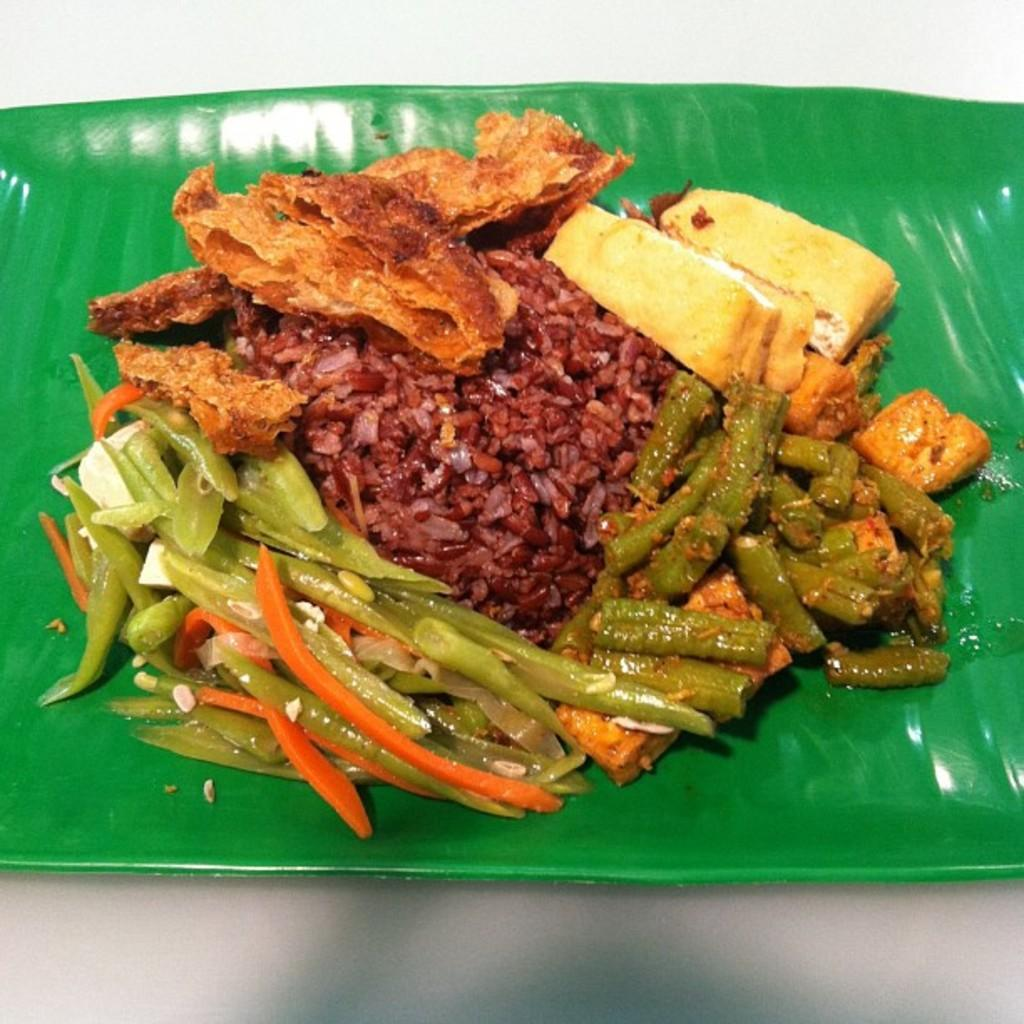What type of food items can be seen in the image? There are food items in the image, but their specific types are not mentioned. How are the food items arranged or presented in the image? The food items are kept on a banana leaf. What type of neck accessory is visible in the image? There is no neck accessory present in the image. What type of jelly is being used as a serving dish for the food items in the image? The food items are kept on a banana leaf, not on jelly. Can you identify any actors in the image? There is no reference to actors or any people in the image. 